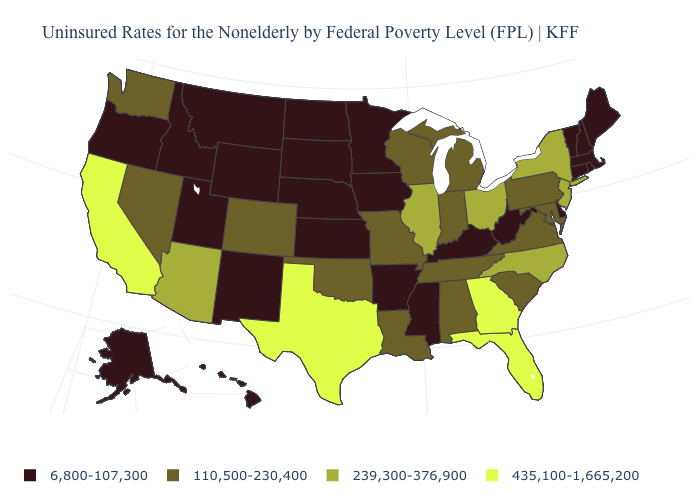What is the value of West Virginia?
Short answer required. 6,800-107,300. What is the value of Massachusetts?
Give a very brief answer. 6,800-107,300. Does New York have a higher value than Arizona?
Keep it brief. No. What is the lowest value in the USA?
Keep it brief. 6,800-107,300. Name the states that have a value in the range 239,300-376,900?
Short answer required. Arizona, Illinois, New Jersey, New York, North Carolina, Ohio. Does Georgia have the highest value in the South?
Quick response, please. Yes. Does Connecticut have the lowest value in the Northeast?
Quick response, please. Yes. Among the states that border Utah , does Arizona have the lowest value?
Concise answer only. No. Name the states that have a value in the range 435,100-1,665,200?
Answer briefly. California, Florida, Georgia, Texas. Name the states that have a value in the range 435,100-1,665,200?
Be succinct. California, Florida, Georgia, Texas. Does the map have missing data?
Answer briefly. No. Does Wisconsin have a lower value than Illinois?
Quick response, please. Yes. Does the map have missing data?
Quick response, please. No. Does Kentucky have the lowest value in the USA?
Keep it brief. Yes. 